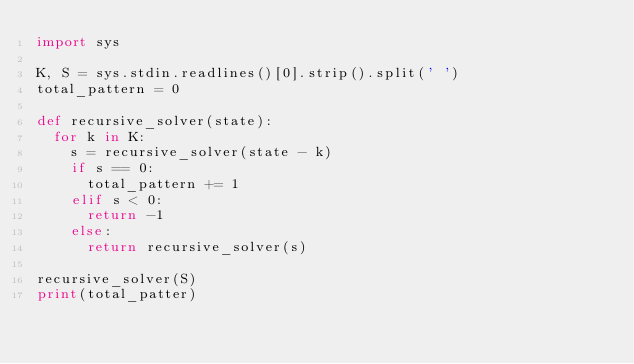<code> <loc_0><loc_0><loc_500><loc_500><_Python_>import sys

K, S = sys.stdin.readlines()[0].strip().split(' ')
total_pattern = 0

def recursive_solver(state):
  for k in K:
    s = recursive_solver(state - k)
    if s == 0:
      total_pattern += 1
    elif s < 0:
      return -1
    else:
      return recursive_solver(s)

recursive_solver(S)
print(total_patter)</code> 